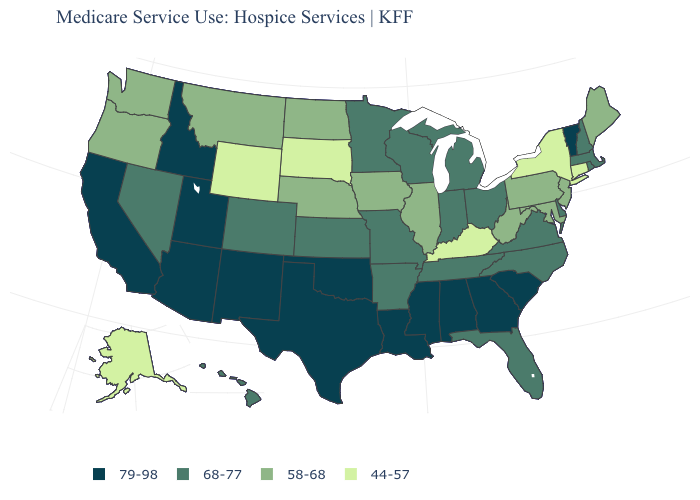Among the states that border Vermont , does New York have the lowest value?
Answer briefly. Yes. Name the states that have a value in the range 44-57?
Short answer required. Alaska, Connecticut, Kentucky, New York, South Dakota, Wyoming. Does the map have missing data?
Concise answer only. No. Among the states that border Massachusetts , does Rhode Island have the highest value?
Short answer required. No. Does Maine have a higher value than Wyoming?
Answer briefly. Yes. Name the states that have a value in the range 79-98?
Short answer required. Alabama, Arizona, California, Georgia, Idaho, Louisiana, Mississippi, New Mexico, Oklahoma, South Carolina, Texas, Utah, Vermont. What is the value of Texas?
Answer briefly. 79-98. Name the states that have a value in the range 44-57?
Concise answer only. Alaska, Connecticut, Kentucky, New York, South Dakota, Wyoming. Is the legend a continuous bar?
Keep it brief. No. How many symbols are there in the legend?
Quick response, please. 4. Which states have the lowest value in the South?
Quick response, please. Kentucky. What is the value of Virginia?
Be succinct. 68-77. Name the states that have a value in the range 44-57?
Concise answer only. Alaska, Connecticut, Kentucky, New York, South Dakota, Wyoming. What is the lowest value in the West?
Keep it brief. 44-57. What is the value of West Virginia?
Answer briefly. 58-68. 